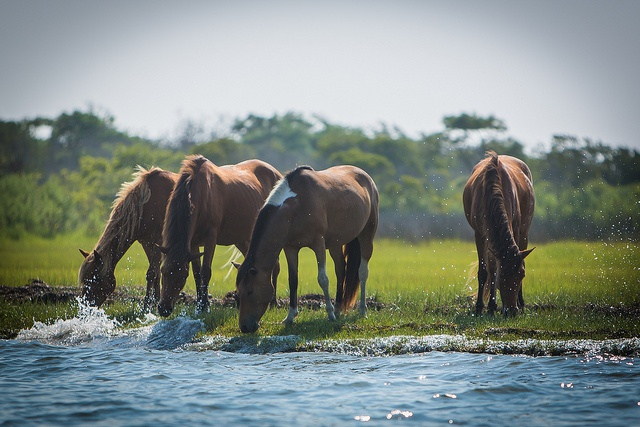Describe the objects in this image and their specific colors. I can see horse in gray and black tones, horse in gray, black, and tan tones, horse in gray and black tones, and horse in gray and black tones in this image. 